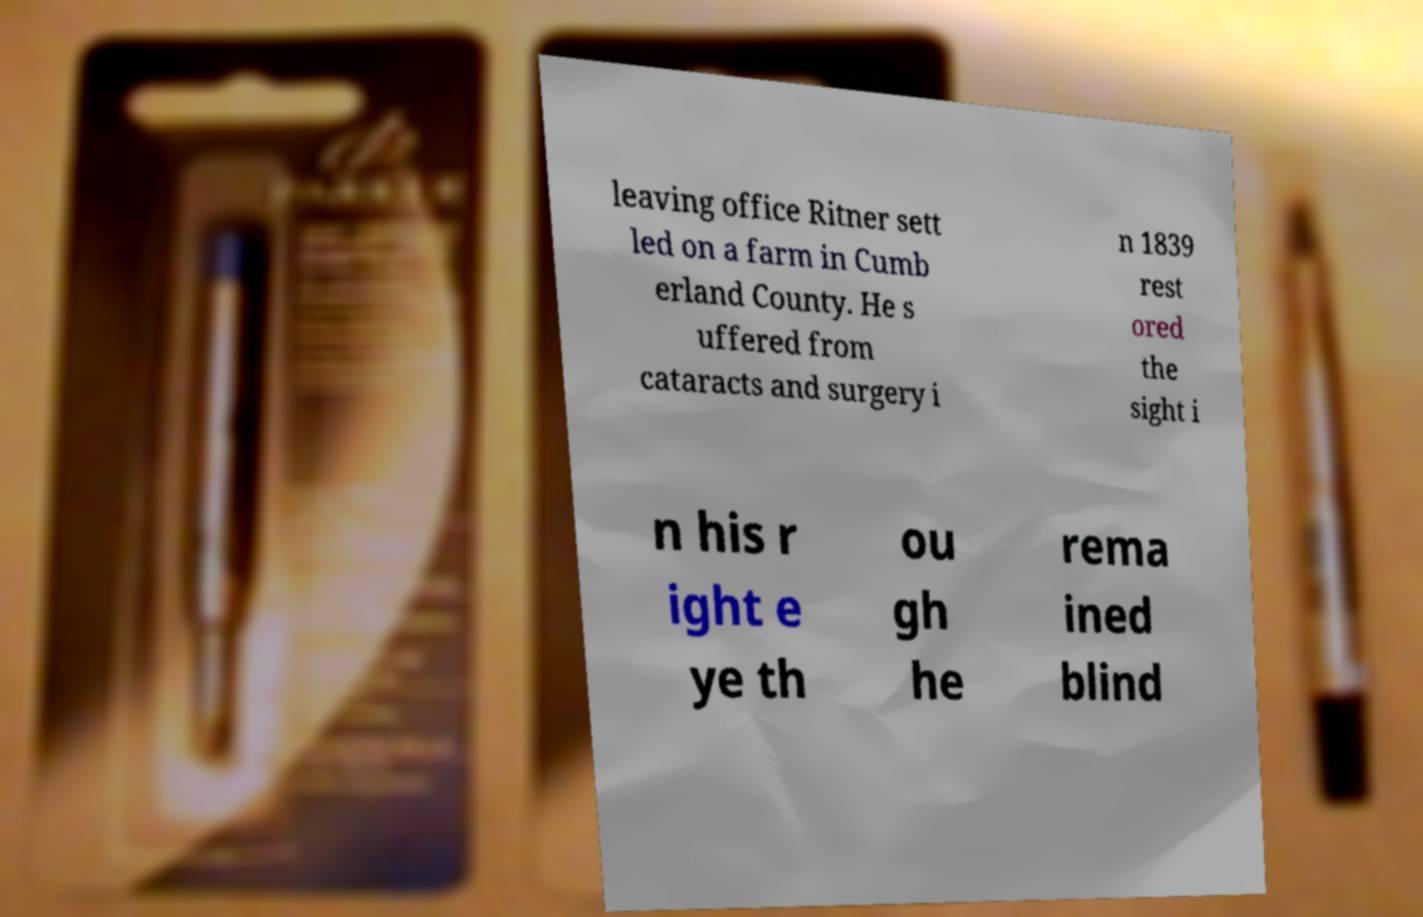Please read and relay the text visible in this image. What does it say? leaving office Ritner sett led on a farm in Cumb erland County. He s uffered from cataracts and surgery i n 1839 rest ored the sight i n his r ight e ye th ou gh he rema ined blind 